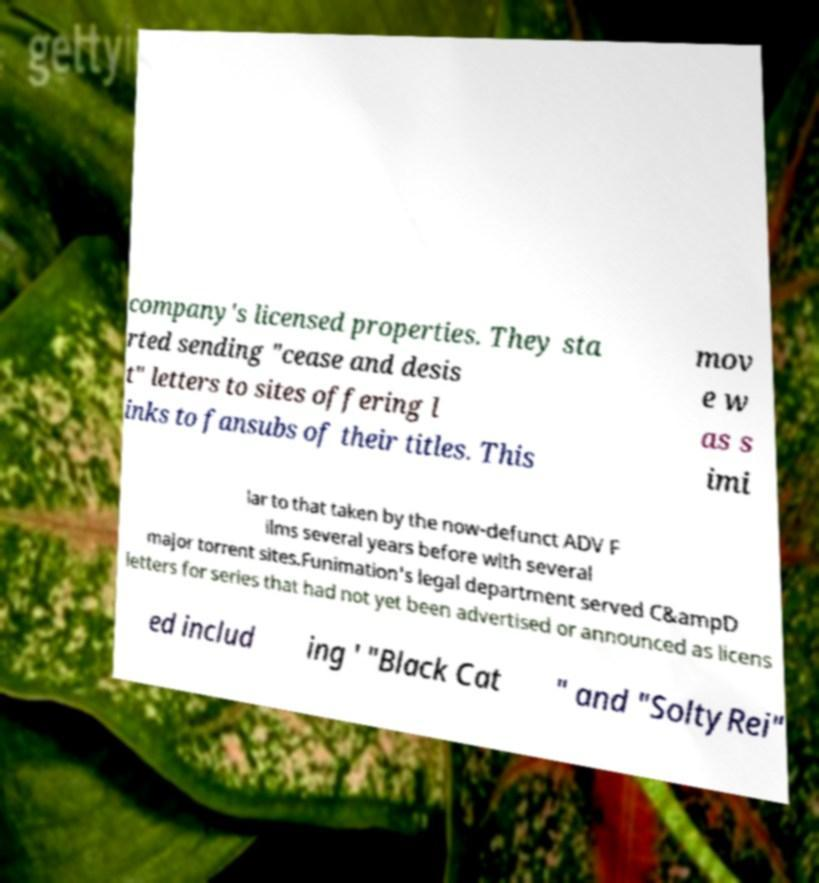I need the written content from this picture converted into text. Can you do that? company's licensed properties. They sta rted sending "cease and desis t" letters to sites offering l inks to fansubs of their titles. This mov e w as s imi lar to that taken by the now-defunct ADV F ilms several years before with several major torrent sites.Funimation's legal department served C&ampD letters for series that had not yet been advertised or announced as licens ed includ ing ' "Black Cat " and "SoltyRei" 